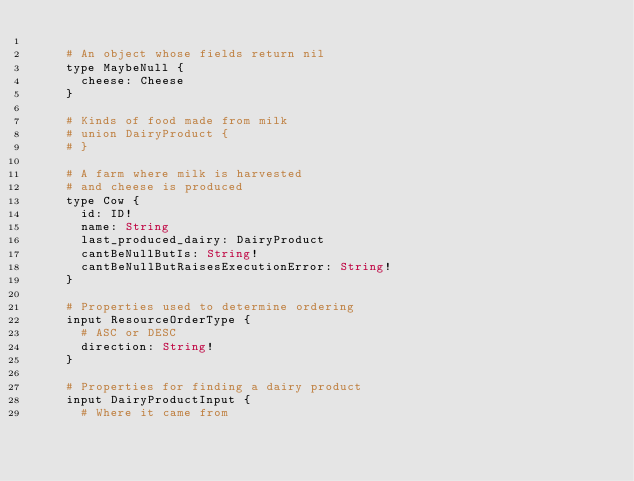Convert code to text. <code><loc_0><loc_0><loc_500><loc_500><_Crystal_>
    # An object whose fields return nil
    type MaybeNull {
      cheese: Cheese
    }

    # Kinds of food made from milk
    # union DairyProduct {
    # }

    # A farm where milk is harvested
    # and cheese is produced
    type Cow {
      id: ID!
      name: String
      last_produced_dairy: DairyProduct
      cantBeNullButIs: String!
      cantBeNullButRaisesExecutionError: String!
    }

    # Properties used to determine ordering
    input ResourceOrderType {
      # ASC or DESC
      direction: String!
    }

    # Properties for finding a dairy product
    input DairyProductInput {
      # Where it came from</code> 